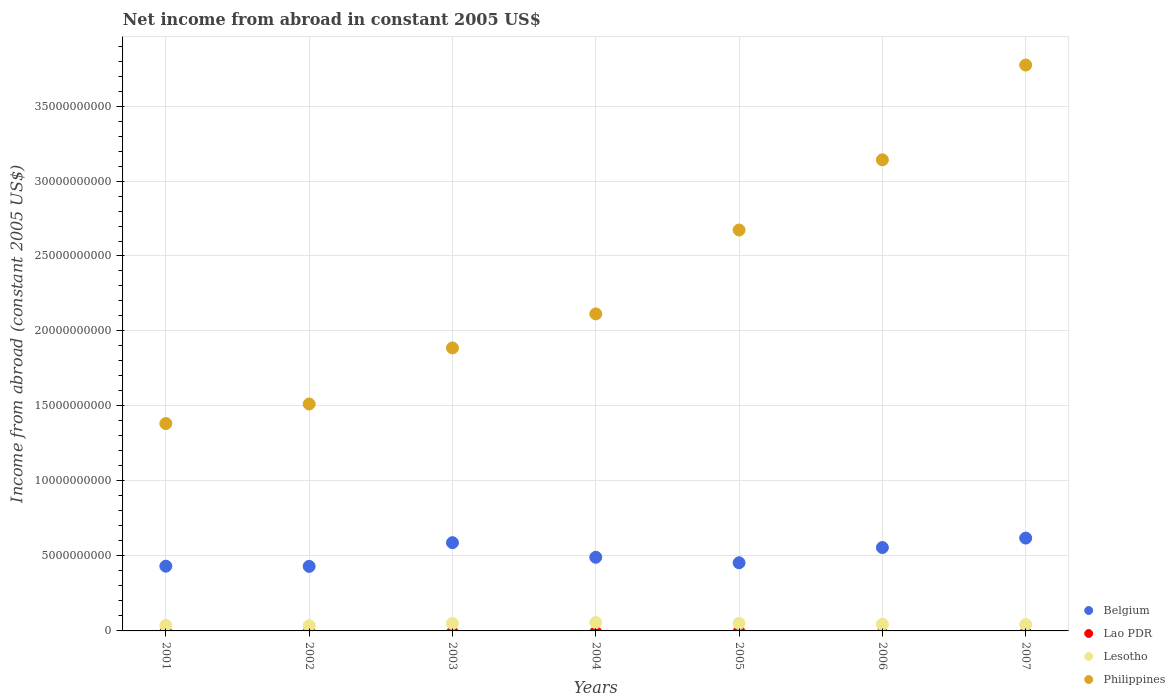What is the net income from abroad in Lao PDR in 2003?
Offer a very short reply. 0. Across all years, what is the maximum net income from abroad in Philippines?
Your answer should be very brief. 3.77e+1. Across all years, what is the minimum net income from abroad in Philippines?
Offer a very short reply. 1.38e+1. In which year was the net income from abroad in Lesotho maximum?
Give a very brief answer. 2004. What is the total net income from abroad in Philippines in the graph?
Offer a very short reply. 1.65e+11. What is the difference between the net income from abroad in Belgium in 2003 and that in 2006?
Provide a short and direct response. 3.24e+08. What is the difference between the net income from abroad in Belgium in 2001 and the net income from abroad in Lao PDR in 2007?
Your answer should be compact. 4.32e+09. What is the average net income from abroad in Lesotho per year?
Offer a terse response. 4.49e+08. In the year 2002, what is the difference between the net income from abroad in Philippines and net income from abroad in Belgium?
Make the answer very short. 1.08e+1. In how many years, is the net income from abroad in Lao PDR greater than 35000000000 US$?
Your answer should be compact. 0. What is the ratio of the net income from abroad in Belgium in 2002 to that in 2003?
Keep it short and to the point. 0.73. Is the net income from abroad in Belgium in 2002 less than that in 2003?
Offer a terse response. Yes. Is the difference between the net income from abroad in Philippines in 2006 and 2007 greater than the difference between the net income from abroad in Belgium in 2006 and 2007?
Give a very brief answer. No. What is the difference between the highest and the second highest net income from abroad in Belgium?
Ensure brevity in your answer.  3.07e+08. What is the difference between the highest and the lowest net income from abroad in Lesotho?
Make the answer very short. 2.14e+08. Is the sum of the net income from abroad in Philippines in 2003 and 2007 greater than the maximum net income from abroad in Lao PDR across all years?
Offer a terse response. Yes. Is it the case that in every year, the sum of the net income from abroad in Lao PDR and net income from abroad in Philippines  is greater than the sum of net income from abroad in Lesotho and net income from abroad in Belgium?
Keep it short and to the point. Yes. Is it the case that in every year, the sum of the net income from abroad in Philippines and net income from abroad in Lao PDR  is greater than the net income from abroad in Belgium?
Offer a very short reply. Yes. Does the net income from abroad in Belgium monotonically increase over the years?
Provide a succinct answer. No. Is the net income from abroad in Lao PDR strictly greater than the net income from abroad in Belgium over the years?
Your answer should be compact. No. How many dotlines are there?
Keep it short and to the point. 3. How many years are there in the graph?
Provide a succinct answer. 7. Does the graph contain any zero values?
Give a very brief answer. Yes. How are the legend labels stacked?
Your answer should be compact. Vertical. What is the title of the graph?
Your answer should be very brief. Net income from abroad in constant 2005 US$. Does "Bangladesh" appear as one of the legend labels in the graph?
Your response must be concise. No. What is the label or title of the X-axis?
Your answer should be compact. Years. What is the label or title of the Y-axis?
Provide a short and direct response. Income from abroad (constant 2005 US$). What is the Income from abroad (constant 2005 US$) of Belgium in 2001?
Provide a short and direct response. 4.32e+09. What is the Income from abroad (constant 2005 US$) of Lao PDR in 2001?
Provide a short and direct response. 0. What is the Income from abroad (constant 2005 US$) of Lesotho in 2001?
Provide a succinct answer. 3.69e+08. What is the Income from abroad (constant 2005 US$) in Philippines in 2001?
Give a very brief answer. 1.38e+1. What is the Income from abroad (constant 2005 US$) of Belgium in 2002?
Offer a terse response. 4.30e+09. What is the Income from abroad (constant 2005 US$) of Lao PDR in 2002?
Offer a terse response. 0. What is the Income from abroad (constant 2005 US$) in Lesotho in 2002?
Provide a succinct answer. 3.48e+08. What is the Income from abroad (constant 2005 US$) in Philippines in 2002?
Your response must be concise. 1.51e+1. What is the Income from abroad (constant 2005 US$) in Belgium in 2003?
Make the answer very short. 5.88e+09. What is the Income from abroad (constant 2005 US$) of Lao PDR in 2003?
Give a very brief answer. 0. What is the Income from abroad (constant 2005 US$) in Lesotho in 2003?
Your answer should be very brief. 4.97e+08. What is the Income from abroad (constant 2005 US$) of Philippines in 2003?
Your answer should be very brief. 1.89e+1. What is the Income from abroad (constant 2005 US$) of Belgium in 2004?
Your response must be concise. 4.91e+09. What is the Income from abroad (constant 2005 US$) in Lesotho in 2004?
Make the answer very short. 5.62e+08. What is the Income from abroad (constant 2005 US$) of Philippines in 2004?
Your answer should be compact. 2.11e+1. What is the Income from abroad (constant 2005 US$) of Belgium in 2005?
Ensure brevity in your answer.  4.54e+09. What is the Income from abroad (constant 2005 US$) in Lao PDR in 2005?
Provide a short and direct response. 0. What is the Income from abroad (constant 2005 US$) of Lesotho in 2005?
Offer a terse response. 5.01e+08. What is the Income from abroad (constant 2005 US$) of Philippines in 2005?
Give a very brief answer. 2.67e+1. What is the Income from abroad (constant 2005 US$) of Belgium in 2006?
Ensure brevity in your answer.  5.56e+09. What is the Income from abroad (constant 2005 US$) in Lao PDR in 2006?
Provide a short and direct response. 0. What is the Income from abroad (constant 2005 US$) of Lesotho in 2006?
Your response must be concise. 4.43e+08. What is the Income from abroad (constant 2005 US$) of Philippines in 2006?
Ensure brevity in your answer.  3.14e+1. What is the Income from abroad (constant 2005 US$) of Belgium in 2007?
Keep it short and to the point. 6.19e+09. What is the Income from abroad (constant 2005 US$) of Lesotho in 2007?
Provide a short and direct response. 4.27e+08. What is the Income from abroad (constant 2005 US$) in Philippines in 2007?
Make the answer very short. 3.77e+1. Across all years, what is the maximum Income from abroad (constant 2005 US$) in Belgium?
Ensure brevity in your answer.  6.19e+09. Across all years, what is the maximum Income from abroad (constant 2005 US$) of Lesotho?
Make the answer very short. 5.62e+08. Across all years, what is the maximum Income from abroad (constant 2005 US$) of Philippines?
Give a very brief answer. 3.77e+1. Across all years, what is the minimum Income from abroad (constant 2005 US$) of Belgium?
Provide a succinct answer. 4.30e+09. Across all years, what is the minimum Income from abroad (constant 2005 US$) of Lesotho?
Keep it short and to the point. 3.48e+08. Across all years, what is the minimum Income from abroad (constant 2005 US$) in Philippines?
Keep it short and to the point. 1.38e+1. What is the total Income from abroad (constant 2005 US$) of Belgium in the graph?
Ensure brevity in your answer.  3.57e+1. What is the total Income from abroad (constant 2005 US$) of Lesotho in the graph?
Your answer should be compact. 3.15e+09. What is the total Income from abroad (constant 2005 US$) of Philippines in the graph?
Keep it short and to the point. 1.65e+11. What is the difference between the Income from abroad (constant 2005 US$) in Belgium in 2001 and that in 2002?
Your response must be concise. 1.22e+07. What is the difference between the Income from abroad (constant 2005 US$) of Lesotho in 2001 and that in 2002?
Your answer should be very brief. 2.12e+07. What is the difference between the Income from abroad (constant 2005 US$) in Philippines in 2001 and that in 2002?
Offer a very short reply. -1.30e+09. What is the difference between the Income from abroad (constant 2005 US$) of Belgium in 2001 and that in 2003?
Offer a terse response. -1.57e+09. What is the difference between the Income from abroad (constant 2005 US$) in Lesotho in 2001 and that in 2003?
Your answer should be very brief. -1.28e+08. What is the difference between the Income from abroad (constant 2005 US$) of Philippines in 2001 and that in 2003?
Ensure brevity in your answer.  -5.04e+09. What is the difference between the Income from abroad (constant 2005 US$) in Belgium in 2001 and that in 2004?
Provide a short and direct response. -5.94e+08. What is the difference between the Income from abroad (constant 2005 US$) in Lesotho in 2001 and that in 2004?
Give a very brief answer. -1.93e+08. What is the difference between the Income from abroad (constant 2005 US$) in Philippines in 2001 and that in 2004?
Your answer should be very brief. -7.31e+09. What is the difference between the Income from abroad (constant 2005 US$) of Belgium in 2001 and that in 2005?
Provide a short and direct response. -2.27e+08. What is the difference between the Income from abroad (constant 2005 US$) of Lesotho in 2001 and that in 2005?
Give a very brief answer. -1.32e+08. What is the difference between the Income from abroad (constant 2005 US$) of Philippines in 2001 and that in 2005?
Your answer should be compact. -1.29e+1. What is the difference between the Income from abroad (constant 2005 US$) of Belgium in 2001 and that in 2006?
Provide a short and direct response. -1.24e+09. What is the difference between the Income from abroad (constant 2005 US$) in Lesotho in 2001 and that in 2006?
Provide a succinct answer. -7.46e+07. What is the difference between the Income from abroad (constant 2005 US$) in Philippines in 2001 and that in 2006?
Offer a very short reply. -1.76e+1. What is the difference between the Income from abroad (constant 2005 US$) of Belgium in 2001 and that in 2007?
Provide a succinct answer. -1.87e+09. What is the difference between the Income from abroad (constant 2005 US$) in Lesotho in 2001 and that in 2007?
Make the answer very short. -5.86e+07. What is the difference between the Income from abroad (constant 2005 US$) of Philippines in 2001 and that in 2007?
Give a very brief answer. -2.39e+1. What is the difference between the Income from abroad (constant 2005 US$) in Belgium in 2002 and that in 2003?
Provide a short and direct response. -1.58e+09. What is the difference between the Income from abroad (constant 2005 US$) of Lesotho in 2002 and that in 2003?
Offer a very short reply. -1.50e+08. What is the difference between the Income from abroad (constant 2005 US$) of Philippines in 2002 and that in 2003?
Your answer should be compact. -3.74e+09. What is the difference between the Income from abroad (constant 2005 US$) in Belgium in 2002 and that in 2004?
Your answer should be compact. -6.07e+08. What is the difference between the Income from abroad (constant 2005 US$) in Lesotho in 2002 and that in 2004?
Provide a succinct answer. -2.14e+08. What is the difference between the Income from abroad (constant 2005 US$) in Philippines in 2002 and that in 2004?
Ensure brevity in your answer.  -6.01e+09. What is the difference between the Income from abroad (constant 2005 US$) in Belgium in 2002 and that in 2005?
Your answer should be compact. -2.39e+08. What is the difference between the Income from abroad (constant 2005 US$) of Lesotho in 2002 and that in 2005?
Your answer should be very brief. -1.54e+08. What is the difference between the Income from abroad (constant 2005 US$) of Philippines in 2002 and that in 2005?
Give a very brief answer. -1.16e+1. What is the difference between the Income from abroad (constant 2005 US$) in Belgium in 2002 and that in 2006?
Keep it short and to the point. -1.26e+09. What is the difference between the Income from abroad (constant 2005 US$) in Lesotho in 2002 and that in 2006?
Your answer should be compact. -9.58e+07. What is the difference between the Income from abroad (constant 2005 US$) of Philippines in 2002 and that in 2006?
Keep it short and to the point. -1.63e+1. What is the difference between the Income from abroad (constant 2005 US$) in Belgium in 2002 and that in 2007?
Offer a very short reply. -1.89e+09. What is the difference between the Income from abroad (constant 2005 US$) of Lesotho in 2002 and that in 2007?
Your answer should be compact. -7.98e+07. What is the difference between the Income from abroad (constant 2005 US$) in Philippines in 2002 and that in 2007?
Your answer should be very brief. -2.26e+1. What is the difference between the Income from abroad (constant 2005 US$) in Belgium in 2003 and that in 2004?
Keep it short and to the point. 9.73e+08. What is the difference between the Income from abroad (constant 2005 US$) of Lesotho in 2003 and that in 2004?
Your response must be concise. -6.46e+07. What is the difference between the Income from abroad (constant 2005 US$) in Philippines in 2003 and that in 2004?
Your answer should be compact. -2.27e+09. What is the difference between the Income from abroad (constant 2005 US$) of Belgium in 2003 and that in 2005?
Provide a succinct answer. 1.34e+09. What is the difference between the Income from abroad (constant 2005 US$) of Lesotho in 2003 and that in 2005?
Offer a terse response. -4.01e+06. What is the difference between the Income from abroad (constant 2005 US$) in Philippines in 2003 and that in 2005?
Make the answer very short. -7.86e+09. What is the difference between the Income from abroad (constant 2005 US$) in Belgium in 2003 and that in 2006?
Offer a very short reply. 3.24e+08. What is the difference between the Income from abroad (constant 2005 US$) in Lesotho in 2003 and that in 2006?
Provide a succinct answer. 5.38e+07. What is the difference between the Income from abroad (constant 2005 US$) in Philippines in 2003 and that in 2006?
Provide a succinct answer. -1.25e+1. What is the difference between the Income from abroad (constant 2005 US$) of Belgium in 2003 and that in 2007?
Make the answer very short. -3.07e+08. What is the difference between the Income from abroad (constant 2005 US$) in Lesotho in 2003 and that in 2007?
Provide a succinct answer. 6.98e+07. What is the difference between the Income from abroad (constant 2005 US$) in Philippines in 2003 and that in 2007?
Provide a succinct answer. -1.89e+1. What is the difference between the Income from abroad (constant 2005 US$) of Belgium in 2004 and that in 2005?
Provide a succinct answer. 3.67e+08. What is the difference between the Income from abroad (constant 2005 US$) in Lesotho in 2004 and that in 2005?
Make the answer very short. 6.06e+07. What is the difference between the Income from abroad (constant 2005 US$) of Philippines in 2004 and that in 2005?
Your answer should be compact. -5.59e+09. What is the difference between the Income from abroad (constant 2005 US$) of Belgium in 2004 and that in 2006?
Offer a very short reply. -6.49e+08. What is the difference between the Income from abroad (constant 2005 US$) of Lesotho in 2004 and that in 2006?
Make the answer very short. 1.18e+08. What is the difference between the Income from abroad (constant 2005 US$) of Philippines in 2004 and that in 2006?
Give a very brief answer. -1.03e+1. What is the difference between the Income from abroad (constant 2005 US$) of Belgium in 2004 and that in 2007?
Offer a terse response. -1.28e+09. What is the difference between the Income from abroad (constant 2005 US$) in Lesotho in 2004 and that in 2007?
Keep it short and to the point. 1.34e+08. What is the difference between the Income from abroad (constant 2005 US$) in Philippines in 2004 and that in 2007?
Give a very brief answer. -1.66e+1. What is the difference between the Income from abroad (constant 2005 US$) of Belgium in 2005 and that in 2006?
Keep it short and to the point. -1.02e+09. What is the difference between the Income from abroad (constant 2005 US$) in Lesotho in 2005 and that in 2006?
Your response must be concise. 5.78e+07. What is the difference between the Income from abroad (constant 2005 US$) of Philippines in 2005 and that in 2006?
Make the answer very short. -4.68e+09. What is the difference between the Income from abroad (constant 2005 US$) of Belgium in 2005 and that in 2007?
Your answer should be compact. -1.65e+09. What is the difference between the Income from abroad (constant 2005 US$) in Lesotho in 2005 and that in 2007?
Make the answer very short. 7.38e+07. What is the difference between the Income from abroad (constant 2005 US$) of Philippines in 2005 and that in 2007?
Your response must be concise. -1.10e+1. What is the difference between the Income from abroad (constant 2005 US$) in Belgium in 2006 and that in 2007?
Make the answer very short. -6.31e+08. What is the difference between the Income from abroad (constant 2005 US$) of Lesotho in 2006 and that in 2007?
Provide a succinct answer. 1.60e+07. What is the difference between the Income from abroad (constant 2005 US$) in Philippines in 2006 and that in 2007?
Offer a very short reply. -6.32e+09. What is the difference between the Income from abroad (constant 2005 US$) in Belgium in 2001 and the Income from abroad (constant 2005 US$) in Lesotho in 2002?
Your response must be concise. 3.97e+09. What is the difference between the Income from abroad (constant 2005 US$) of Belgium in 2001 and the Income from abroad (constant 2005 US$) of Philippines in 2002?
Offer a very short reply. -1.08e+1. What is the difference between the Income from abroad (constant 2005 US$) of Lesotho in 2001 and the Income from abroad (constant 2005 US$) of Philippines in 2002?
Make the answer very short. -1.48e+1. What is the difference between the Income from abroad (constant 2005 US$) in Belgium in 2001 and the Income from abroad (constant 2005 US$) in Lesotho in 2003?
Your response must be concise. 3.82e+09. What is the difference between the Income from abroad (constant 2005 US$) of Belgium in 2001 and the Income from abroad (constant 2005 US$) of Philippines in 2003?
Your response must be concise. -1.46e+1. What is the difference between the Income from abroad (constant 2005 US$) in Lesotho in 2001 and the Income from abroad (constant 2005 US$) in Philippines in 2003?
Your answer should be compact. -1.85e+1. What is the difference between the Income from abroad (constant 2005 US$) in Belgium in 2001 and the Income from abroad (constant 2005 US$) in Lesotho in 2004?
Your answer should be compact. 3.75e+09. What is the difference between the Income from abroad (constant 2005 US$) in Belgium in 2001 and the Income from abroad (constant 2005 US$) in Philippines in 2004?
Make the answer very short. -1.68e+1. What is the difference between the Income from abroad (constant 2005 US$) of Lesotho in 2001 and the Income from abroad (constant 2005 US$) of Philippines in 2004?
Give a very brief answer. -2.08e+1. What is the difference between the Income from abroad (constant 2005 US$) in Belgium in 2001 and the Income from abroad (constant 2005 US$) in Lesotho in 2005?
Provide a short and direct response. 3.82e+09. What is the difference between the Income from abroad (constant 2005 US$) in Belgium in 2001 and the Income from abroad (constant 2005 US$) in Philippines in 2005?
Offer a very short reply. -2.24e+1. What is the difference between the Income from abroad (constant 2005 US$) in Lesotho in 2001 and the Income from abroad (constant 2005 US$) in Philippines in 2005?
Offer a very short reply. -2.64e+1. What is the difference between the Income from abroad (constant 2005 US$) in Belgium in 2001 and the Income from abroad (constant 2005 US$) in Lesotho in 2006?
Give a very brief answer. 3.87e+09. What is the difference between the Income from abroad (constant 2005 US$) of Belgium in 2001 and the Income from abroad (constant 2005 US$) of Philippines in 2006?
Offer a terse response. -2.71e+1. What is the difference between the Income from abroad (constant 2005 US$) of Lesotho in 2001 and the Income from abroad (constant 2005 US$) of Philippines in 2006?
Your response must be concise. -3.10e+1. What is the difference between the Income from abroad (constant 2005 US$) of Belgium in 2001 and the Income from abroad (constant 2005 US$) of Lesotho in 2007?
Ensure brevity in your answer.  3.89e+09. What is the difference between the Income from abroad (constant 2005 US$) of Belgium in 2001 and the Income from abroad (constant 2005 US$) of Philippines in 2007?
Your response must be concise. -3.34e+1. What is the difference between the Income from abroad (constant 2005 US$) in Lesotho in 2001 and the Income from abroad (constant 2005 US$) in Philippines in 2007?
Ensure brevity in your answer.  -3.74e+1. What is the difference between the Income from abroad (constant 2005 US$) of Belgium in 2002 and the Income from abroad (constant 2005 US$) of Lesotho in 2003?
Ensure brevity in your answer.  3.81e+09. What is the difference between the Income from abroad (constant 2005 US$) of Belgium in 2002 and the Income from abroad (constant 2005 US$) of Philippines in 2003?
Provide a succinct answer. -1.46e+1. What is the difference between the Income from abroad (constant 2005 US$) of Lesotho in 2002 and the Income from abroad (constant 2005 US$) of Philippines in 2003?
Offer a terse response. -1.85e+1. What is the difference between the Income from abroad (constant 2005 US$) in Belgium in 2002 and the Income from abroad (constant 2005 US$) in Lesotho in 2004?
Offer a very short reply. 3.74e+09. What is the difference between the Income from abroad (constant 2005 US$) in Belgium in 2002 and the Income from abroad (constant 2005 US$) in Philippines in 2004?
Offer a terse response. -1.68e+1. What is the difference between the Income from abroad (constant 2005 US$) in Lesotho in 2002 and the Income from abroad (constant 2005 US$) in Philippines in 2004?
Make the answer very short. -2.08e+1. What is the difference between the Income from abroad (constant 2005 US$) in Belgium in 2002 and the Income from abroad (constant 2005 US$) in Lesotho in 2005?
Ensure brevity in your answer.  3.80e+09. What is the difference between the Income from abroad (constant 2005 US$) in Belgium in 2002 and the Income from abroad (constant 2005 US$) in Philippines in 2005?
Offer a very short reply. -2.24e+1. What is the difference between the Income from abroad (constant 2005 US$) of Lesotho in 2002 and the Income from abroad (constant 2005 US$) of Philippines in 2005?
Provide a short and direct response. -2.64e+1. What is the difference between the Income from abroad (constant 2005 US$) in Belgium in 2002 and the Income from abroad (constant 2005 US$) in Lesotho in 2006?
Make the answer very short. 3.86e+09. What is the difference between the Income from abroad (constant 2005 US$) of Belgium in 2002 and the Income from abroad (constant 2005 US$) of Philippines in 2006?
Your answer should be very brief. -2.71e+1. What is the difference between the Income from abroad (constant 2005 US$) in Lesotho in 2002 and the Income from abroad (constant 2005 US$) in Philippines in 2006?
Offer a very short reply. -3.11e+1. What is the difference between the Income from abroad (constant 2005 US$) of Belgium in 2002 and the Income from abroad (constant 2005 US$) of Lesotho in 2007?
Keep it short and to the point. 3.88e+09. What is the difference between the Income from abroad (constant 2005 US$) of Belgium in 2002 and the Income from abroad (constant 2005 US$) of Philippines in 2007?
Provide a succinct answer. -3.34e+1. What is the difference between the Income from abroad (constant 2005 US$) of Lesotho in 2002 and the Income from abroad (constant 2005 US$) of Philippines in 2007?
Provide a short and direct response. -3.74e+1. What is the difference between the Income from abroad (constant 2005 US$) in Belgium in 2003 and the Income from abroad (constant 2005 US$) in Lesotho in 2004?
Your answer should be compact. 5.32e+09. What is the difference between the Income from abroad (constant 2005 US$) in Belgium in 2003 and the Income from abroad (constant 2005 US$) in Philippines in 2004?
Your answer should be compact. -1.53e+1. What is the difference between the Income from abroad (constant 2005 US$) of Lesotho in 2003 and the Income from abroad (constant 2005 US$) of Philippines in 2004?
Give a very brief answer. -2.06e+1. What is the difference between the Income from abroad (constant 2005 US$) in Belgium in 2003 and the Income from abroad (constant 2005 US$) in Lesotho in 2005?
Give a very brief answer. 5.38e+09. What is the difference between the Income from abroad (constant 2005 US$) of Belgium in 2003 and the Income from abroad (constant 2005 US$) of Philippines in 2005?
Give a very brief answer. -2.08e+1. What is the difference between the Income from abroad (constant 2005 US$) in Lesotho in 2003 and the Income from abroad (constant 2005 US$) in Philippines in 2005?
Provide a succinct answer. -2.62e+1. What is the difference between the Income from abroad (constant 2005 US$) in Belgium in 2003 and the Income from abroad (constant 2005 US$) in Lesotho in 2006?
Provide a short and direct response. 5.44e+09. What is the difference between the Income from abroad (constant 2005 US$) of Belgium in 2003 and the Income from abroad (constant 2005 US$) of Philippines in 2006?
Your answer should be very brief. -2.55e+1. What is the difference between the Income from abroad (constant 2005 US$) of Lesotho in 2003 and the Income from abroad (constant 2005 US$) of Philippines in 2006?
Offer a terse response. -3.09e+1. What is the difference between the Income from abroad (constant 2005 US$) in Belgium in 2003 and the Income from abroad (constant 2005 US$) in Lesotho in 2007?
Offer a terse response. 5.46e+09. What is the difference between the Income from abroad (constant 2005 US$) of Belgium in 2003 and the Income from abroad (constant 2005 US$) of Philippines in 2007?
Ensure brevity in your answer.  -3.19e+1. What is the difference between the Income from abroad (constant 2005 US$) in Lesotho in 2003 and the Income from abroad (constant 2005 US$) in Philippines in 2007?
Provide a short and direct response. -3.72e+1. What is the difference between the Income from abroad (constant 2005 US$) in Belgium in 2004 and the Income from abroad (constant 2005 US$) in Lesotho in 2005?
Your answer should be very brief. 4.41e+09. What is the difference between the Income from abroad (constant 2005 US$) of Belgium in 2004 and the Income from abroad (constant 2005 US$) of Philippines in 2005?
Your answer should be very brief. -2.18e+1. What is the difference between the Income from abroad (constant 2005 US$) in Lesotho in 2004 and the Income from abroad (constant 2005 US$) in Philippines in 2005?
Ensure brevity in your answer.  -2.62e+1. What is the difference between the Income from abroad (constant 2005 US$) in Belgium in 2004 and the Income from abroad (constant 2005 US$) in Lesotho in 2006?
Offer a very short reply. 4.47e+09. What is the difference between the Income from abroad (constant 2005 US$) in Belgium in 2004 and the Income from abroad (constant 2005 US$) in Philippines in 2006?
Provide a succinct answer. -2.65e+1. What is the difference between the Income from abroad (constant 2005 US$) in Lesotho in 2004 and the Income from abroad (constant 2005 US$) in Philippines in 2006?
Make the answer very short. -3.09e+1. What is the difference between the Income from abroad (constant 2005 US$) in Belgium in 2004 and the Income from abroad (constant 2005 US$) in Lesotho in 2007?
Provide a succinct answer. 4.48e+09. What is the difference between the Income from abroad (constant 2005 US$) in Belgium in 2004 and the Income from abroad (constant 2005 US$) in Philippines in 2007?
Give a very brief answer. -3.28e+1. What is the difference between the Income from abroad (constant 2005 US$) in Lesotho in 2004 and the Income from abroad (constant 2005 US$) in Philippines in 2007?
Your response must be concise. -3.72e+1. What is the difference between the Income from abroad (constant 2005 US$) in Belgium in 2005 and the Income from abroad (constant 2005 US$) in Lesotho in 2006?
Your answer should be compact. 4.10e+09. What is the difference between the Income from abroad (constant 2005 US$) of Belgium in 2005 and the Income from abroad (constant 2005 US$) of Philippines in 2006?
Make the answer very short. -2.69e+1. What is the difference between the Income from abroad (constant 2005 US$) in Lesotho in 2005 and the Income from abroad (constant 2005 US$) in Philippines in 2006?
Ensure brevity in your answer.  -3.09e+1. What is the difference between the Income from abroad (constant 2005 US$) in Belgium in 2005 and the Income from abroad (constant 2005 US$) in Lesotho in 2007?
Provide a short and direct response. 4.12e+09. What is the difference between the Income from abroad (constant 2005 US$) of Belgium in 2005 and the Income from abroad (constant 2005 US$) of Philippines in 2007?
Offer a very short reply. -3.32e+1. What is the difference between the Income from abroad (constant 2005 US$) in Lesotho in 2005 and the Income from abroad (constant 2005 US$) in Philippines in 2007?
Provide a succinct answer. -3.72e+1. What is the difference between the Income from abroad (constant 2005 US$) in Belgium in 2006 and the Income from abroad (constant 2005 US$) in Lesotho in 2007?
Offer a terse response. 5.13e+09. What is the difference between the Income from abroad (constant 2005 US$) in Belgium in 2006 and the Income from abroad (constant 2005 US$) in Philippines in 2007?
Make the answer very short. -3.22e+1. What is the difference between the Income from abroad (constant 2005 US$) of Lesotho in 2006 and the Income from abroad (constant 2005 US$) of Philippines in 2007?
Keep it short and to the point. -3.73e+1. What is the average Income from abroad (constant 2005 US$) of Belgium per year?
Your response must be concise. 5.10e+09. What is the average Income from abroad (constant 2005 US$) in Lao PDR per year?
Provide a short and direct response. 0. What is the average Income from abroad (constant 2005 US$) in Lesotho per year?
Offer a terse response. 4.49e+08. What is the average Income from abroad (constant 2005 US$) of Philippines per year?
Your response must be concise. 2.35e+1. In the year 2001, what is the difference between the Income from abroad (constant 2005 US$) of Belgium and Income from abroad (constant 2005 US$) of Lesotho?
Keep it short and to the point. 3.95e+09. In the year 2001, what is the difference between the Income from abroad (constant 2005 US$) of Belgium and Income from abroad (constant 2005 US$) of Philippines?
Provide a succinct answer. -9.51e+09. In the year 2001, what is the difference between the Income from abroad (constant 2005 US$) in Lesotho and Income from abroad (constant 2005 US$) in Philippines?
Provide a short and direct response. -1.35e+1. In the year 2002, what is the difference between the Income from abroad (constant 2005 US$) in Belgium and Income from abroad (constant 2005 US$) in Lesotho?
Keep it short and to the point. 3.96e+09. In the year 2002, what is the difference between the Income from abroad (constant 2005 US$) of Belgium and Income from abroad (constant 2005 US$) of Philippines?
Make the answer very short. -1.08e+1. In the year 2002, what is the difference between the Income from abroad (constant 2005 US$) of Lesotho and Income from abroad (constant 2005 US$) of Philippines?
Your answer should be very brief. -1.48e+1. In the year 2003, what is the difference between the Income from abroad (constant 2005 US$) of Belgium and Income from abroad (constant 2005 US$) of Lesotho?
Offer a terse response. 5.39e+09. In the year 2003, what is the difference between the Income from abroad (constant 2005 US$) of Belgium and Income from abroad (constant 2005 US$) of Philippines?
Your answer should be very brief. -1.30e+1. In the year 2003, what is the difference between the Income from abroad (constant 2005 US$) in Lesotho and Income from abroad (constant 2005 US$) in Philippines?
Make the answer very short. -1.84e+1. In the year 2004, what is the difference between the Income from abroad (constant 2005 US$) of Belgium and Income from abroad (constant 2005 US$) of Lesotho?
Ensure brevity in your answer.  4.35e+09. In the year 2004, what is the difference between the Income from abroad (constant 2005 US$) in Belgium and Income from abroad (constant 2005 US$) in Philippines?
Provide a short and direct response. -1.62e+1. In the year 2004, what is the difference between the Income from abroad (constant 2005 US$) in Lesotho and Income from abroad (constant 2005 US$) in Philippines?
Offer a very short reply. -2.06e+1. In the year 2005, what is the difference between the Income from abroad (constant 2005 US$) in Belgium and Income from abroad (constant 2005 US$) in Lesotho?
Your answer should be very brief. 4.04e+09. In the year 2005, what is the difference between the Income from abroad (constant 2005 US$) of Belgium and Income from abroad (constant 2005 US$) of Philippines?
Provide a short and direct response. -2.22e+1. In the year 2005, what is the difference between the Income from abroad (constant 2005 US$) in Lesotho and Income from abroad (constant 2005 US$) in Philippines?
Ensure brevity in your answer.  -2.62e+1. In the year 2006, what is the difference between the Income from abroad (constant 2005 US$) of Belgium and Income from abroad (constant 2005 US$) of Lesotho?
Your answer should be compact. 5.12e+09. In the year 2006, what is the difference between the Income from abroad (constant 2005 US$) of Belgium and Income from abroad (constant 2005 US$) of Philippines?
Make the answer very short. -2.59e+1. In the year 2006, what is the difference between the Income from abroad (constant 2005 US$) in Lesotho and Income from abroad (constant 2005 US$) in Philippines?
Offer a very short reply. -3.10e+1. In the year 2007, what is the difference between the Income from abroad (constant 2005 US$) in Belgium and Income from abroad (constant 2005 US$) in Lesotho?
Keep it short and to the point. 5.76e+09. In the year 2007, what is the difference between the Income from abroad (constant 2005 US$) in Belgium and Income from abroad (constant 2005 US$) in Philippines?
Ensure brevity in your answer.  -3.15e+1. In the year 2007, what is the difference between the Income from abroad (constant 2005 US$) of Lesotho and Income from abroad (constant 2005 US$) of Philippines?
Your response must be concise. -3.73e+1. What is the ratio of the Income from abroad (constant 2005 US$) in Belgium in 2001 to that in 2002?
Your answer should be compact. 1. What is the ratio of the Income from abroad (constant 2005 US$) in Lesotho in 2001 to that in 2002?
Your response must be concise. 1.06. What is the ratio of the Income from abroad (constant 2005 US$) of Philippines in 2001 to that in 2002?
Your answer should be compact. 0.91. What is the ratio of the Income from abroad (constant 2005 US$) of Belgium in 2001 to that in 2003?
Your response must be concise. 0.73. What is the ratio of the Income from abroad (constant 2005 US$) of Lesotho in 2001 to that in 2003?
Provide a short and direct response. 0.74. What is the ratio of the Income from abroad (constant 2005 US$) in Philippines in 2001 to that in 2003?
Make the answer very short. 0.73. What is the ratio of the Income from abroad (constant 2005 US$) of Belgium in 2001 to that in 2004?
Make the answer very short. 0.88. What is the ratio of the Income from abroad (constant 2005 US$) of Lesotho in 2001 to that in 2004?
Provide a succinct answer. 0.66. What is the ratio of the Income from abroad (constant 2005 US$) of Philippines in 2001 to that in 2004?
Offer a very short reply. 0.65. What is the ratio of the Income from abroad (constant 2005 US$) of Lesotho in 2001 to that in 2005?
Make the answer very short. 0.74. What is the ratio of the Income from abroad (constant 2005 US$) in Philippines in 2001 to that in 2005?
Give a very brief answer. 0.52. What is the ratio of the Income from abroad (constant 2005 US$) in Belgium in 2001 to that in 2006?
Keep it short and to the point. 0.78. What is the ratio of the Income from abroad (constant 2005 US$) in Lesotho in 2001 to that in 2006?
Provide a succinct answer. 0.83. What is the ratio of the Income from abroad (constant 2005 US$) in Philippines in 2001 to that in 2006?
Give a very brief answer. 0.44. What is the ratio of the Income from abroad (constant 2005 US$) in Belgium in 2001 to that in 2007?
Give a very brief answer. 0.7. What is the ratio of the Income from abroad (constant 2005 US$) of Lesotho in 2001 to that in 2007?
Provide a short and direct response. 0.86. What is the ratio of the Income from abroad (constant 2005 US$) of Philippines in 2001 to that in 2007?
Your answer should be compact. 0.37. What is the ratio of the Income from abroad (constant 2005 US$) of Belgium in 2002 to that in 2003?
Ensure brevity in your answer.  0.73. What is the ratio of the Income from abroad (constant 2005 US$) in Lesotho in 2002 to that in 2003?
Offer a very short reply. 0.7. What is the ratio of the Income from abroad (constant 2005 US$) of Philippines in 2002 to that in 2003?
Your answer should be compact. 0.8. What is the ratio of the Income from abroad (constant 2005 US$) of Belgium in 2002 to that in 2004?
Make the answer very short. 0.88. What is the ratio of the Income from abroad (constant 2005 US$) of Lesotho in 2002 to that in 2004?
Offer a very short reply. 0.62. What is the ratio of the Income from abroad (constant 2005 US$) in Philippines in 2002 to that in 2004?
Offer a terse response. 0.72. What is the ratio of the Income from abroad (constant 2005 US$) of Belgium in 2002 to that in 2005?
Offer a very short reply. 0.95. What is the ratio of the Income from abroad (constant 2005 US$) of Lesotho in 2002 to that in 2005?
Give a very brief answer. 0.69. What is the ratio of the Income from abroad (constant 2005 US$) of Philippines in 2002 to that in 2005?
Give a very brief answer. 0.57. What is the ratio of the Income from abroad (constant 2005 US$) of Belgium in 2002 to that in 2006?
Provide a short and direct response. 0.77. What is the ratio of the Income from abroad (constant 2005 US$) of Lesotho in 2002 to that in 2006?
Provide a short and direct response. 0.78. What is the ratio of the Income from abroad (constant 2005 US$) of Philippines in 2002 to that in 2006?
Keep it short and to the point. 0.48. What is the ratio of the Income from abroad (constant 2005 US$) in Belgium in 2002 to that in 2007?
Keep it short and to the point. 0.7. What is the ratio of the Income from abroad (constant 2005 US$) in Lesotho in 2002 to that in 2007?
Make the answer very short. 0.81. What is the ratio of the Income from abroad (constant 2005 US$) in Philippines in 2002 to that in 2007?
Offer a terse response. 0.4. What is the ratio of the Income from abroad (constant 2005 US$) of Belgium in 2003 to that in 2004?
Your response must be concise. 1.2. What is the ratio of the Income from abroad (constant 2005 US$) in Lesotho in 2003 to that in 2004?
Provide a succinct answer. 0.89. What is the ratio of the Income from abroad (constant 2005 US$) of Philippines in 2003 to that in 2004?
Offer a terse response. 0.89. What is the ratio of the Income from abroad (constant 2005 US$) of Belgium in 2003 to that in 2005?
Give a very brief answer. 1.29. What is the ratio of the Income from abroad (constant 2005 US$) in Philippines in 2003 to that in 2005?
Offer a very short reply. 0.71. What is the ratio of the Income from abroad (constant 2005 US$) of Belgium in 2003 to that in 2006?
Your response must be concise. 1.06. What is the ratio of the Income from abroad (constant 2005 US$) of Lesotho in 2003 to that in 2006?
Ensure brevity in your answer.  1.12. What is the ratio of the Income from abroad (constant 2005 US$) of Philippines in 2003 to that in 2006?
Make the answer very short. 0.6. What is the ratio of the Income from abroad (constant 2005 US$) in Belgium in 2003 to that in 2007?
Offer a terse response. 0.95. What is the ratio of the Income from abroad (constant 2005 US$) in Lesotho in 2003 to that in 2007?
Offer a very short reply. 1.16. What is the ratio of the Income from abroad (constant 2005 US$) in Philippines in 2003 to that in 2007?
Your response must be concise. 0.5. What is the ratio of the Income from abroad (constant 2005 US$) in Belgium in 2004 to that in 2005?
Give a very brief answer. 1.08. What is the ratio of the Income from abroad (constant 2005 US$) of Lesotho in 2004 to that in 2005?
Your answer should be compact. 1.12. What is the ratio of the Income from abroad (constant 2005 US$) in Philippines in 2004 to that in 2005?
Offer a very short reply. 0.79. What is the ratio of the Income from abroad (constant 2005 US$) of Belgium in 2004 to that in 2006?
Your answer should be very brief. 0.88. What is the ratio of the Income from abroad (constant 2005 US$) in Lesotho in 2004 to that in 2006?
Keep it short and to the point. 1.27. What is the ratio of the Income from abroad (constant 2005 US$) in Philippines in 2004 to that in 2006?
Provide a succinct answer. 0.67. What is the ratio of the Income from abroad (constant 2005 US$) in Belgium in 2004 to that in 2007?
Ensure brevity in your answer.  0.79. What is the ratio of the Income from abroad (constant 2005 US$) in Lesotho in 2004 to that in 2007?
Give a very brief answer. 1.31. What is the ratio of the Income from abroad (constant 2005 US$) in Philippines in 2004 to that in 2007?
Give a very brief answer. 0.56. What is the ratio of the Income from abroad (constant 2005 US$) of Belgium in 2005 to that in 2006?
Provide a short and direct response. 0.82. What is the ratio of the Income from abroad (constant 2005 US$) of Lesotho in 2005 to that in 2006?
Give a very brief answer. 1.13. What is the ratio of the Income from abroad (constant 2005 US$) in Philippines in 2005 to that in 2006?
Ensure brevity in your answer.  0.85. What is the ratio of the Income from abroad (constant 2005 US$) in Belgium in 2005 to that in 2007?
Provide a short and direct response. 0.73. What is the ratio of the Income from abroad (constant 2005 US$) in Lesotho in 2005 to that in 2007?
Your answer should be compact. 1.17. What is the ratio of the Income from abroad (constant 2005 US$) in Philippines in 2005 to that in 2007?
Make the answer very short. 0.71. What is the ratio of the Income from abroad (constant 2005 US$) in Belgium in 2006 to that in 2007?
Make the answer very short. 0.9. What is the ratio of the Income from abroad (constant 2005 US$) of Lesotho in 2006 to that in 2007?
Offer a terse response. 1.04. What is the ratio of the Income from abroad (constant 2005 US$) of Philippines in 2006 to that in 2007?
Keep it short and to the point. 0.83. What is the difference between the highest and the second highest Income from abroad (constant 2005 US$) of Belgium?
Provide a short and direct response. 3.07e+08. What is the difference between the highest and the second highest Income from abroad (constant 2005 US$) in Lesotho?
Offer a terse response. 6.06e+07. What is the difference between the highest and the second highest Income from abroad (constant 2005 US$) in Philippines?
Provide a succinct answer. 6.32e+09. What is the difference between the highest and the lowest Income from abroad (constant 2005 US$) of Belgium?
Provide a short and direct response. 1.89e+09. What is the difference between the highest and the lowest Income from abroad (constant 2005 US$) of Lesotho?
Provide a short and direct response. 2.14e+08. What is the difference between the highest and the lowest Income from abroad (constant 2005 US$) in Philippines?
Your response must be concise. 2.39e+1. 